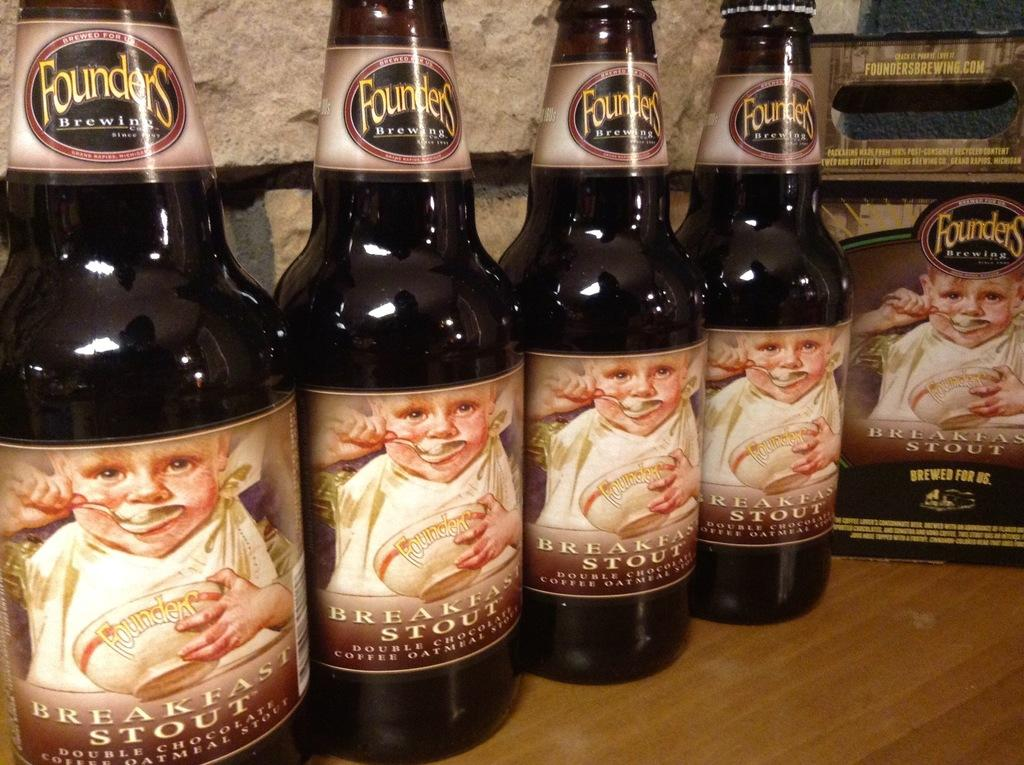<image>
Relay a brief, clear account of the picture shown. Four bottles of Founders Brewing Co. Breakfast Stout on a table 